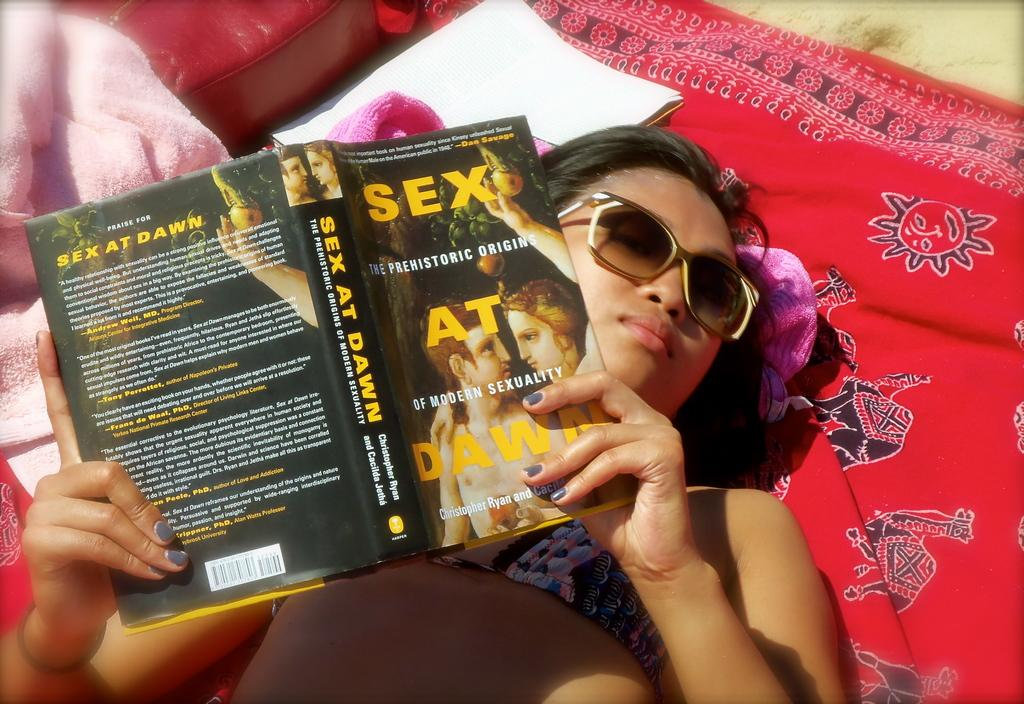Who is the main subject in the image? There is a woman in the image. What is the woman doing in the image? The woman is laying on a red cloth and reading a book. What else can be seen near the woman in the image? There is a towel beside the woman. What type of donkey can be seen tasting the book in the image? There is no donkey present in the image, and the book is not being tasted by any animal. 